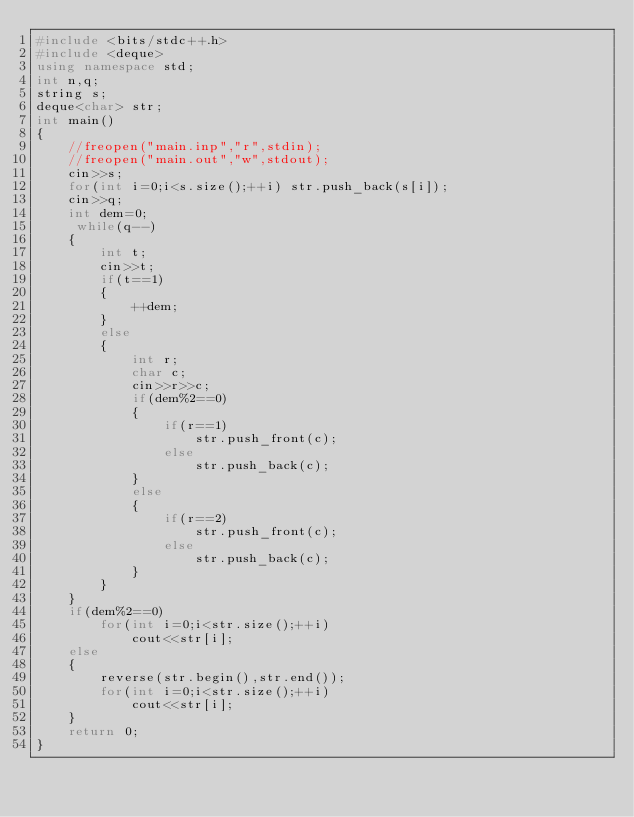<code> <loc_0><loc_0><loc_500><loc_500><_C++_>#include <bits/stdc++.h>
#include <deque>
using namespace std;
int n,q;
string s;
deque<char> str;
int main()
{
    //freopen("main.inp","r",stdin);
    //freopen("main.out","w",stdout);
    cin>>s;
    for(int i=0;i<s.size();++i) str.push_back(s[i]);
    cin>>q;
    int dem=0;
     while(q--)
    {
        int t;
        cin>>t;
        if(t==1)
        {
            ++dem;
        }
        else
        {
            int r;
            char c;
            cin>>r>>c;
            if(dem%2==0)
            {
                if(r==1)
                    str.push_front(c);
                else
                    str.push_back(c);
            }
            else
            {
                if(r==2)
                    str.push_front(c);
                else
                    str.push_back(c);
            }
        }
    }
    if(dem%2==0)
        for(int i=0;i<str.size();++i)
            cout<<str[i];
    else
    {
        reverse(str.begin(),str.end());
        for(int i=0;i<str.size();++i)
            cout<<str[i];
    }
    return 0;
}
</code> 